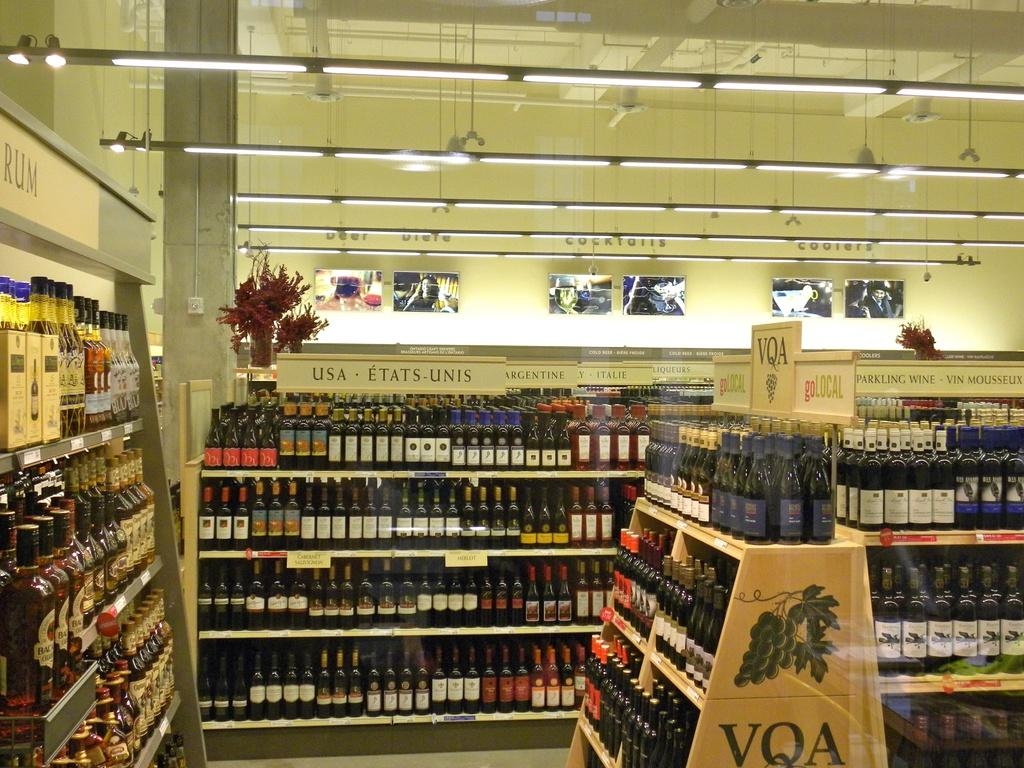<image>
Create a compact narrative representing the image presented. Several bottles of wine are displayed on a VQA wine rack at the liquor store. 